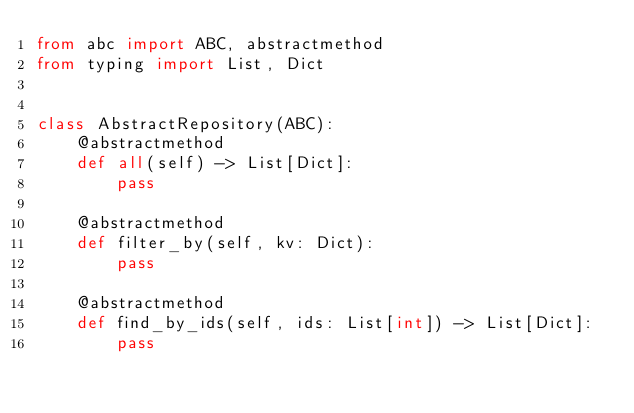Convert code to text. <code><loc_0><loc_0><loc_500><loc_500><_Python_>from abc import ABC, abstractmethod
from typing import List, Dict


class AbstractRepository(ABC):
    @abstractmethod
    def all(self) -> List[Dict]:
        pass

    @abstractmethod
    def filter_by(self, kv: Dict):
        pass

    @abstractmethod
    def find_by_ids(self, ids: List[int]) -> List[Dict]:
        pass
</code> 